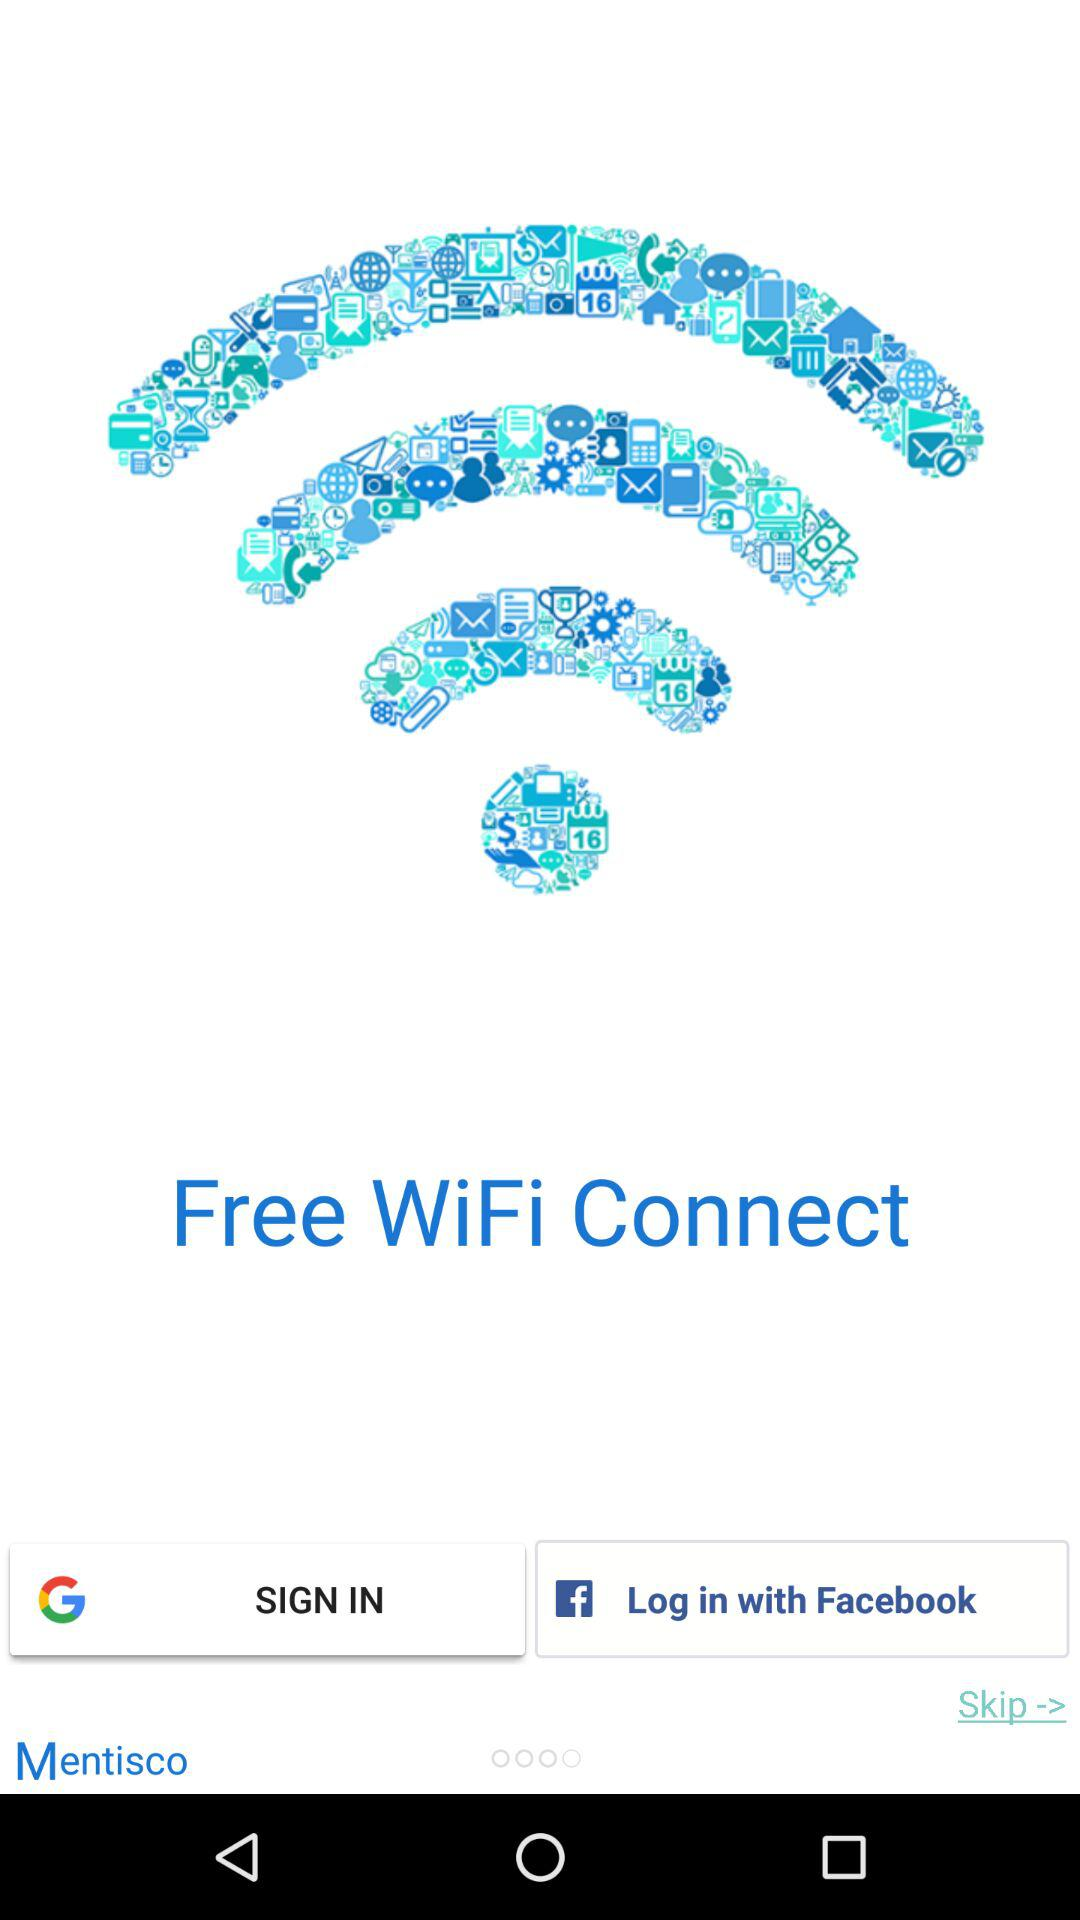What are the different options available for logging in? The different options available for logging in are "Google" and "Facebook". 